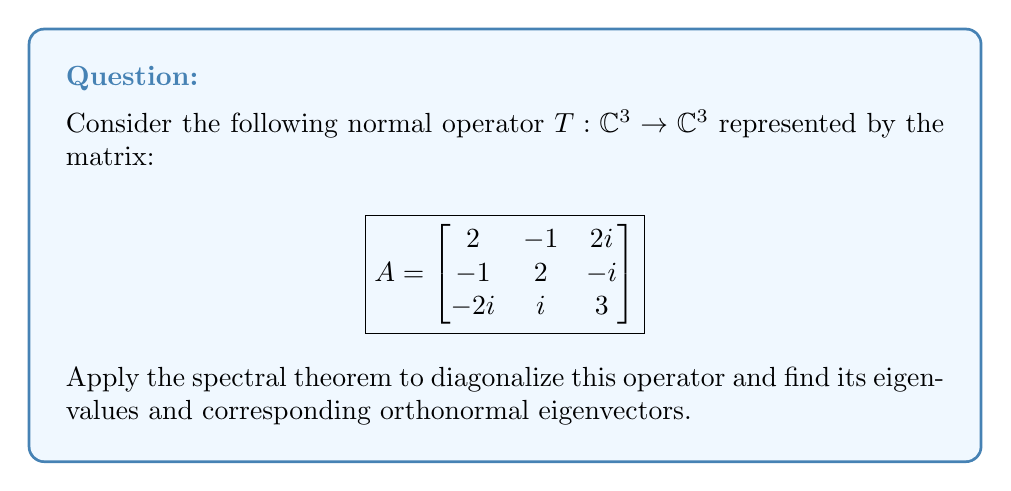Solve this math problem. 1) First, we need to verify that $A$ is indeed normal, i.e., $AA^* = A^*A$. We can skip this step as it's given in the question.

2) To find the eigenvalues, we solve the characteristic equation:
   $$\det(A - \lambda I) = 0$$
   
   $$\begin{vmatrix}
   2-\lambda & -1 & 2i \\
   -1 & 2-\lambda & -i \\
   -2i & i & 3-\lambda
   \end{vmatrix} = 0$$

3) Expanding this determinant:
   $(\lambda-1)(\lambda-2)(\lambda-4) = 0$

4) So, the eigenvalues are $\lambda_1 = 1$, $\lambda_2 = 2$, and $\lambda_3 = 4$.

5) For each eigenvalue, we find the corresponding eigenvector:

   For $\lambda_1 = 1$:
   $(A - I)\mathbf{v}_1 = \mathbf{0}$
   Solving this, we get $\mathbf{v}_1 = (1, -1, 0)^T$

   For $\lambda_2 = 2$:
   $(A - 2I)\mathbf{v}_2 = \mathbf{0}$
   Solving this, we get $\mathbf{v}_2 = (1, 1, -i)^T$

   For $\lambda_3 = 4$:
   $(A - 4I)\mathbf{v}_3 = \mathbf{0}$
   Solving this, we get $\mathbf{v}_3 = (1, 1, 2i)^T$

6) We normalize these eigenvectors:
   $\mathbf{u}_1 = \frac{1}{\sqrt{2}}(1, -1, 0)^T$
   $\mathbf{u}_2 = \frac{1}{\sqrt{3}}(1, 1, -i)^T$
   $\mathbf{u}_3 = \frac{1}{\sqrt{6}}(1, 1, 2i)^T$

7) The spectral theorem states that for a normal operator $T$, there exists an orthonormal basis of eigenvectors. We've found this basis: $\{\mathbf{u}_1, \mathbf{u}_2, \mathbf{u}_3\}$.

8) The diagonalization is given by:
   $A = UDU^*$
   where $D$ is a diagonal matrix of eigenvalues and $U$ is the matrix of orthonormal eigenvectors.

   $$D = \begin{bmatrix}
   1 & 0 & 0 \\
   0 & 2 & 0 \\
   0 & 0 & 4
   \end{bmatrix}$$

   $$U = \begin{bmatrix}
   \frac{1}{\sqrt{2}} & \frac{1}{\sqrt{3}} & \frac{1}{\sqrt{6}} \\
   -\frac{1}{\sqrt{2}} & \frac{1}{\sqrt{3}} & \frac{1}{\sqrt{6}} \\
   0 & -\frac{i}{\sqrt{3}} & \frac{2i}{\sqrt{6}}
   \end{bmatrix}$$
Answer: $A = UDU^*$, where $D = \text{diag}(1,2,4)$ and $U = [\mathbf{u}_1 \; \mathbf{u}_2 \; \mathbf{u}_3]$ with $\mathbf{u}_1 = \frac{1}{\sqrt{2}}(1, -1, 0)^T$, $\mathbf{u}_2 = \frac{1}{\sqrt{3}}(1, 1, -i)^T$, $\mathbf{u}_3 = \frac{1}{\sqrt{6}}(1, 1, 2i)^T$. 